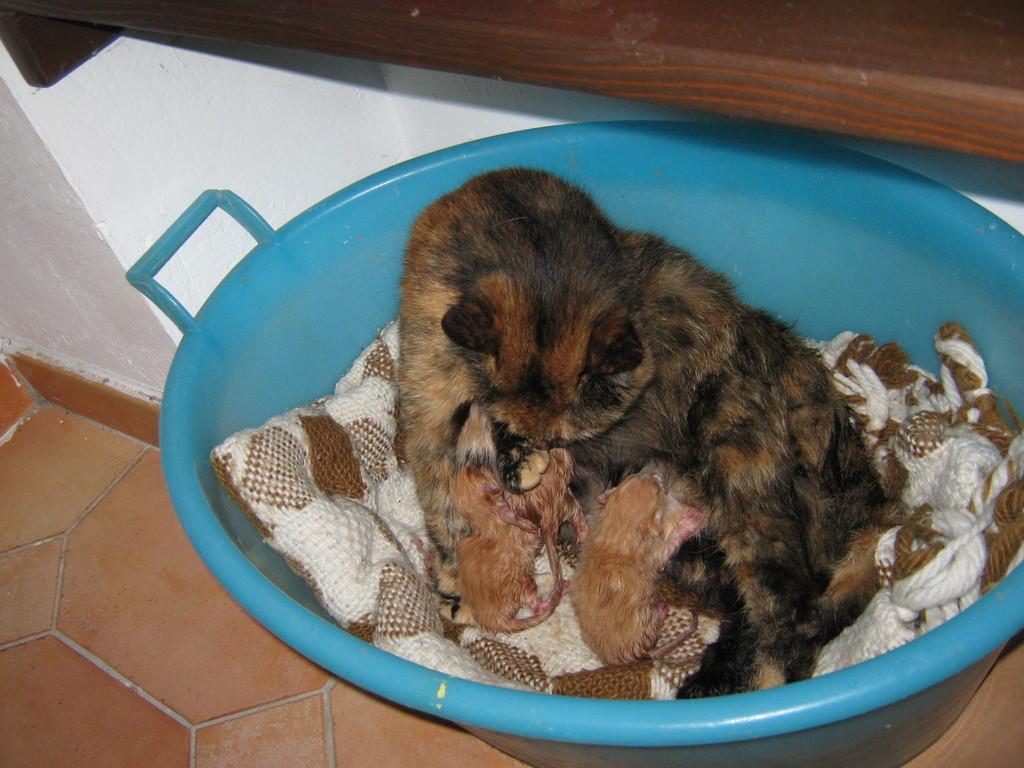Can you describe this image briefly? In this picture we can see a brown color cat sitting in the blue tub with two baby kittens. Behind we can see a white wall and wooden shelf. 